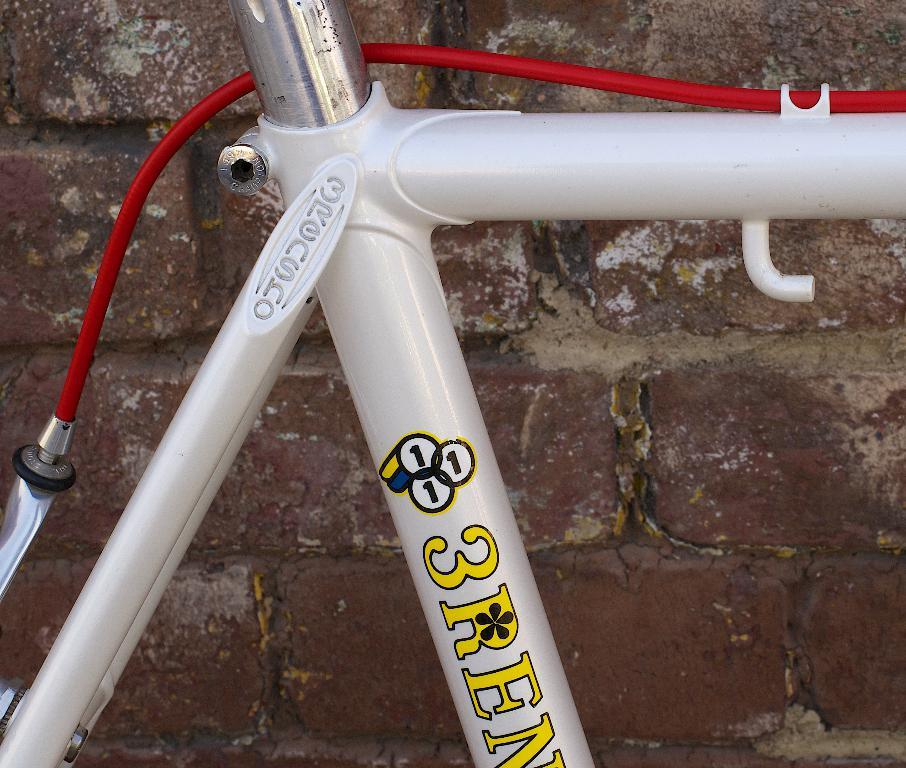What objects can be seen in the image? There are rods and a cable in the image. What is visible in the background of the image? There is a wall in the background of the image. What type of knife is being used to cut the rods in the image? There is no knife present in the image, and the rods are not being cut. 